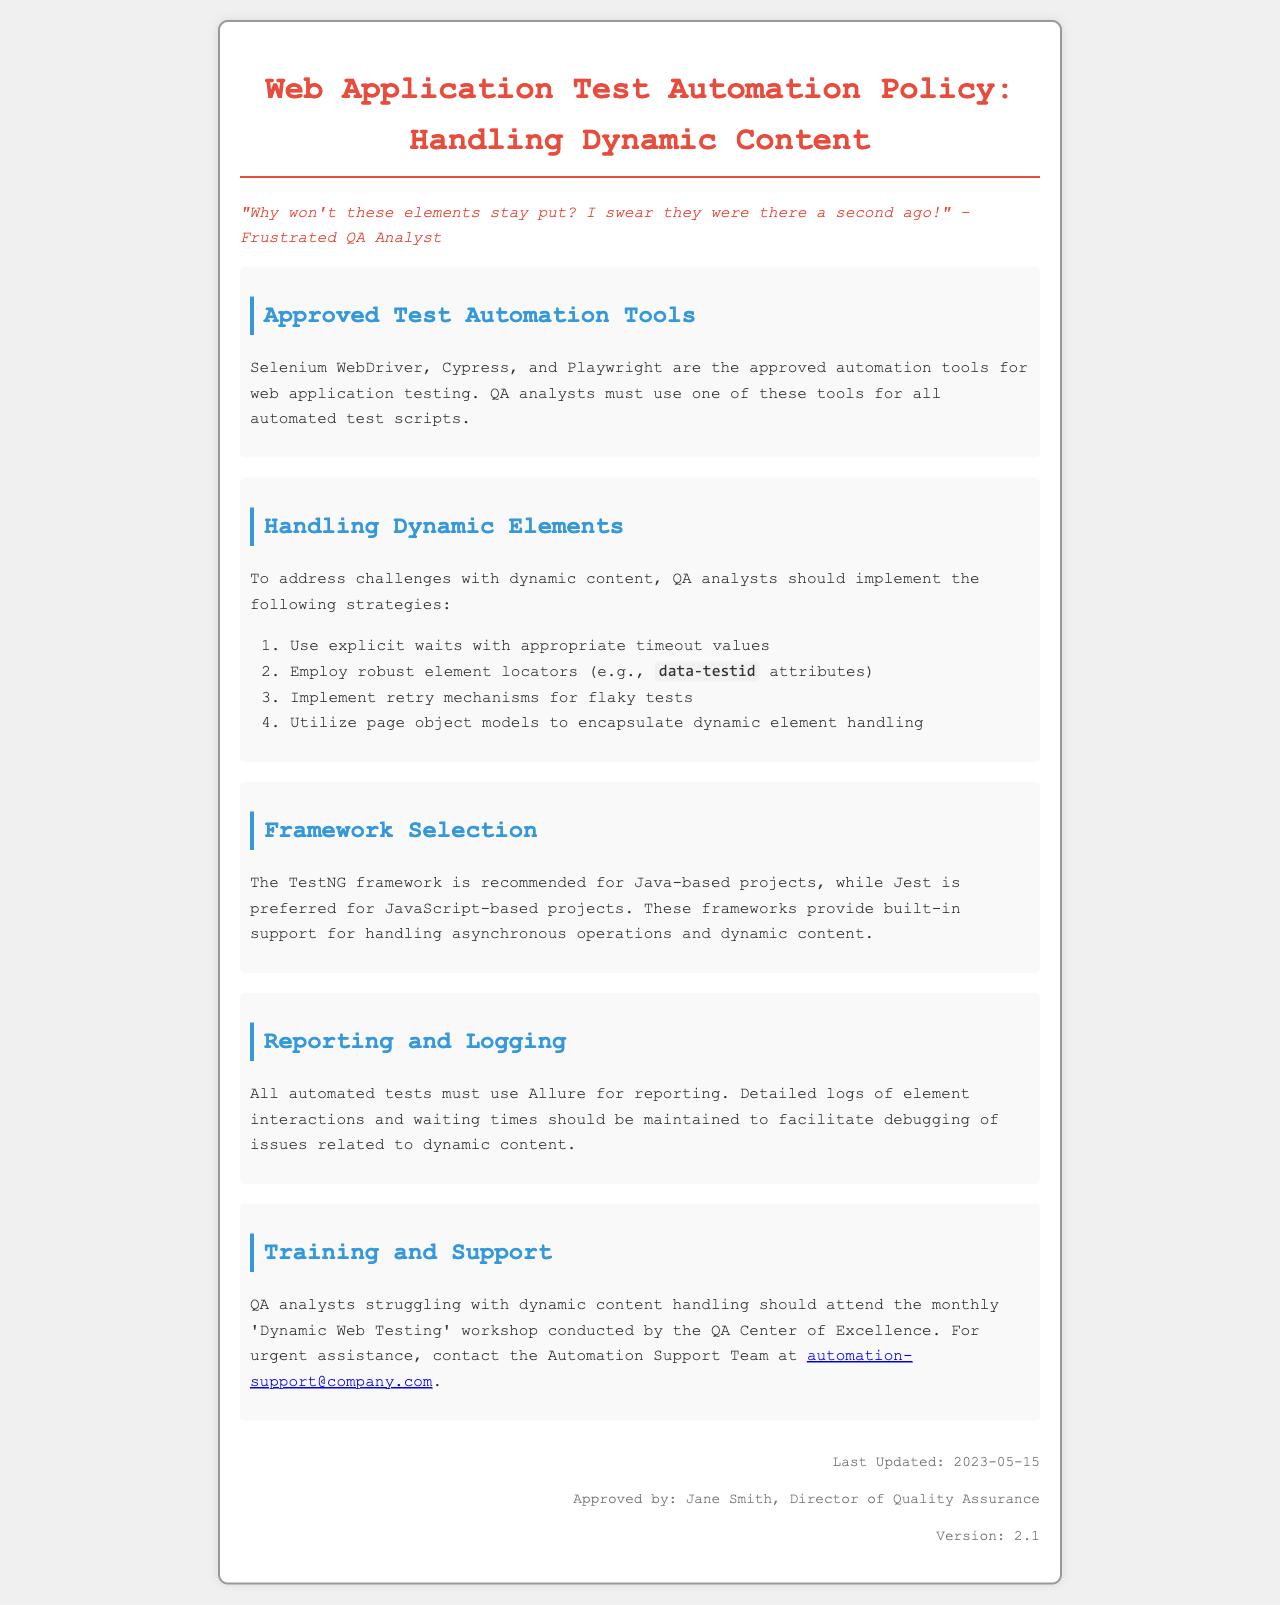What are the approved test automation tools? The approved automation tools for web application testing are listed in the document, which are Selenium WebDriver, Cypress, and Playwright.
Answer: Selenium WebDriver, Cypress, Playwright What strategies should be implemented to handle dynamic elements? The document outlines specific strategies for handling dynamic elements, which includes using explicit waits, robust element locators, retry mechanisms, and page object models.
Answer: Explicit waits, robust element locators, retry mechanisms, page object models Who is the approved director of Quality Assurance? The document states that Jane Smith is the Director of Quality Assurance who approved this policy.
Answer: Jane Smith What framework is recommended for JavaScript-based projects? The document mentions Jest as the recommended framework for JavaScript-based projects.
Answer: Jest What should be used for reporting automated tests? It specifies that Allure must be used for reporting all automated tests in the document.
Answer: Allure How often is the 'Dynamic Web Testing' workshop conducted? The document says the workshop is conducted monthly for analysts struggling with dynamic content handling.
Answer: Monthly What is the last update date of the policy? The document states the last updated date of the policy as May 15, 2023.
Answer: 2023-05-15 How should detailed logs of element interactions be maintained? The document emphasizes that detailed logs must be maintained to facilitate debugging related to dynamic content.
Answer: Maintain detailed logs 